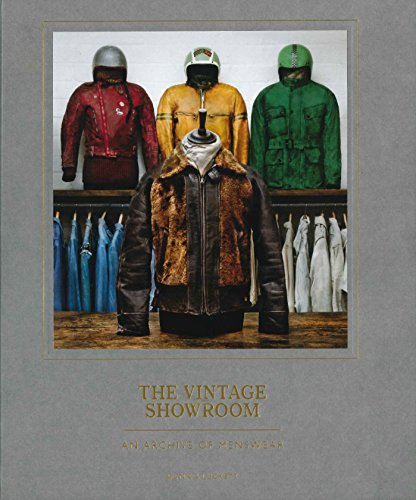Who wrote this book? The book, 'The Vintage Showroom: Vintage Menswear 2', was written by Douglas Gunn along with a co-author, showcasing their expertise on vintage fashion. 